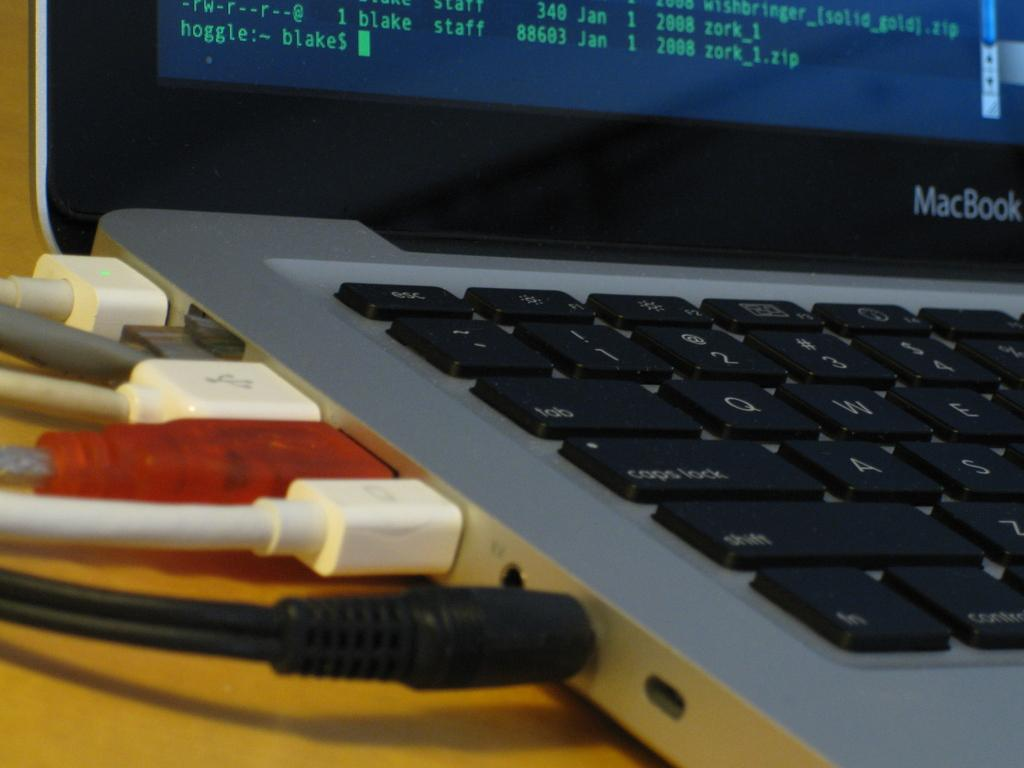<image>
Share a concise interpretation of the image provided. A side view of a MacBook showing its cord ports. 